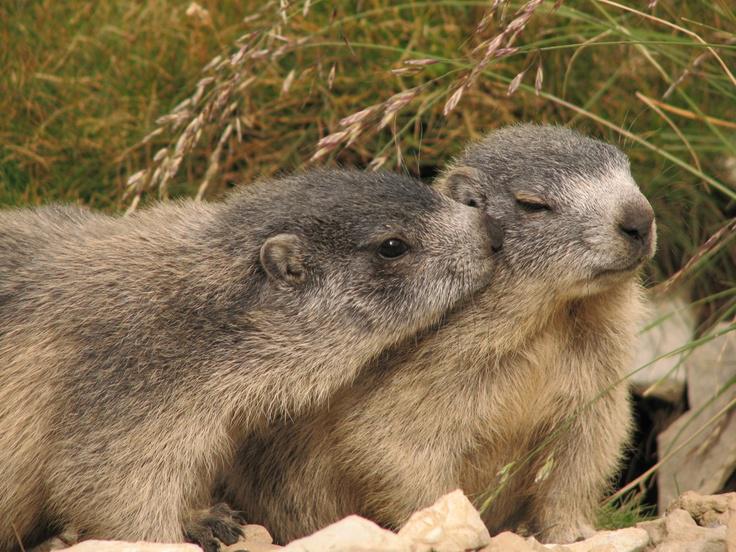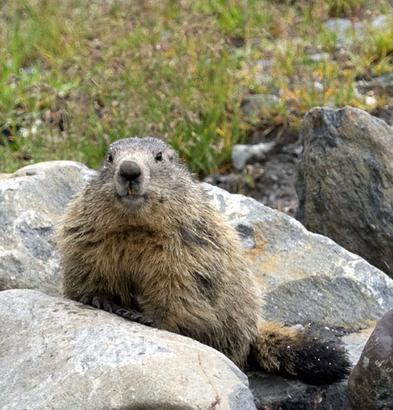The first image is the image on the left, the second image is the image on the right. For the images shown, is this caption "There is only one animal is eating." true? Answer yes or no. No. The first image is the image on the left, the second image is the image on the right. Given the left and right images, does the statement "There are at least two animals in the image on the right." hold true? Answer yes or no. No. 